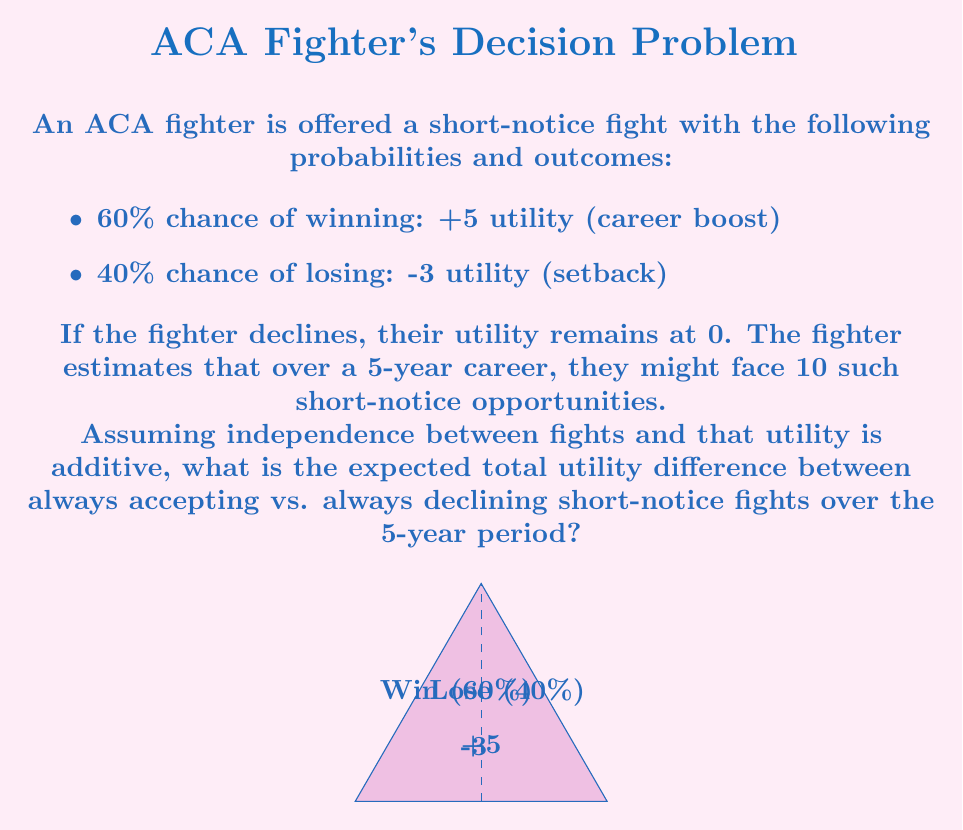Give your solution to this math problem. Let's approach this step-by-step:

1) First, let's calculate the expected utility of accepting one short-notice fight:

   $E(U) = 0.6 \cdot 5 + 0.4 \cdot (-3) = 3 - 1.2 = 1.8$

2) The expected utility of declining is always 0.

3) Therefore, the expected utility difference for one fight is:

   $1.8 - 0 = 1.8$

4) Over a 5-year career with 10 such opportunities, assuming independence and additive utility, we multiply this difference by 10:

   $10 \cdot 1.8 = 18$

5) We can also express this mathematically as:

   $$E(U_{total}) = 10 \cdot (0.6 \cdot 5 + 0.4 \cdot (-3)) - 10 \cdot 0 = 18$$

   Where $10$ is the number of opportunities, the terms in parentheses represent the expected utility of accepting one fight, and $0$ is the utility of declining.

This result suggests that, on average, always accepting short-notice fights would yield 18 more utility points over the 5-year period compared to always declining.
Answer: 18 utility points 